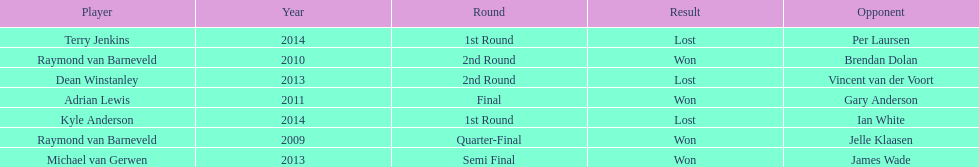Name a year with more than one game listed. 2013. 